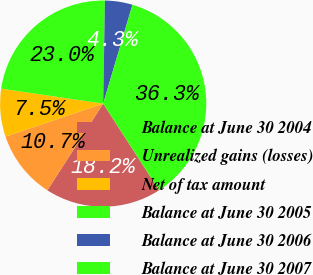Convert chart. <chart><loc_0><loc_0><loc_500><loc_500><pie_chart><fcel>Balance at June 30 2004<fcel>Unrealized gains (losses)<fcel>Net of tax amount<fcel>Balance at June 30 2005<fcel>Balance at June 30 2006<fcel>Balance at June 30 2007<nl><fcel>18.22%<fcel>10.71%<fcel>7.51%<fcel>22.95%<fcel>4.31%<fcel>36.3%<nl></chart> 